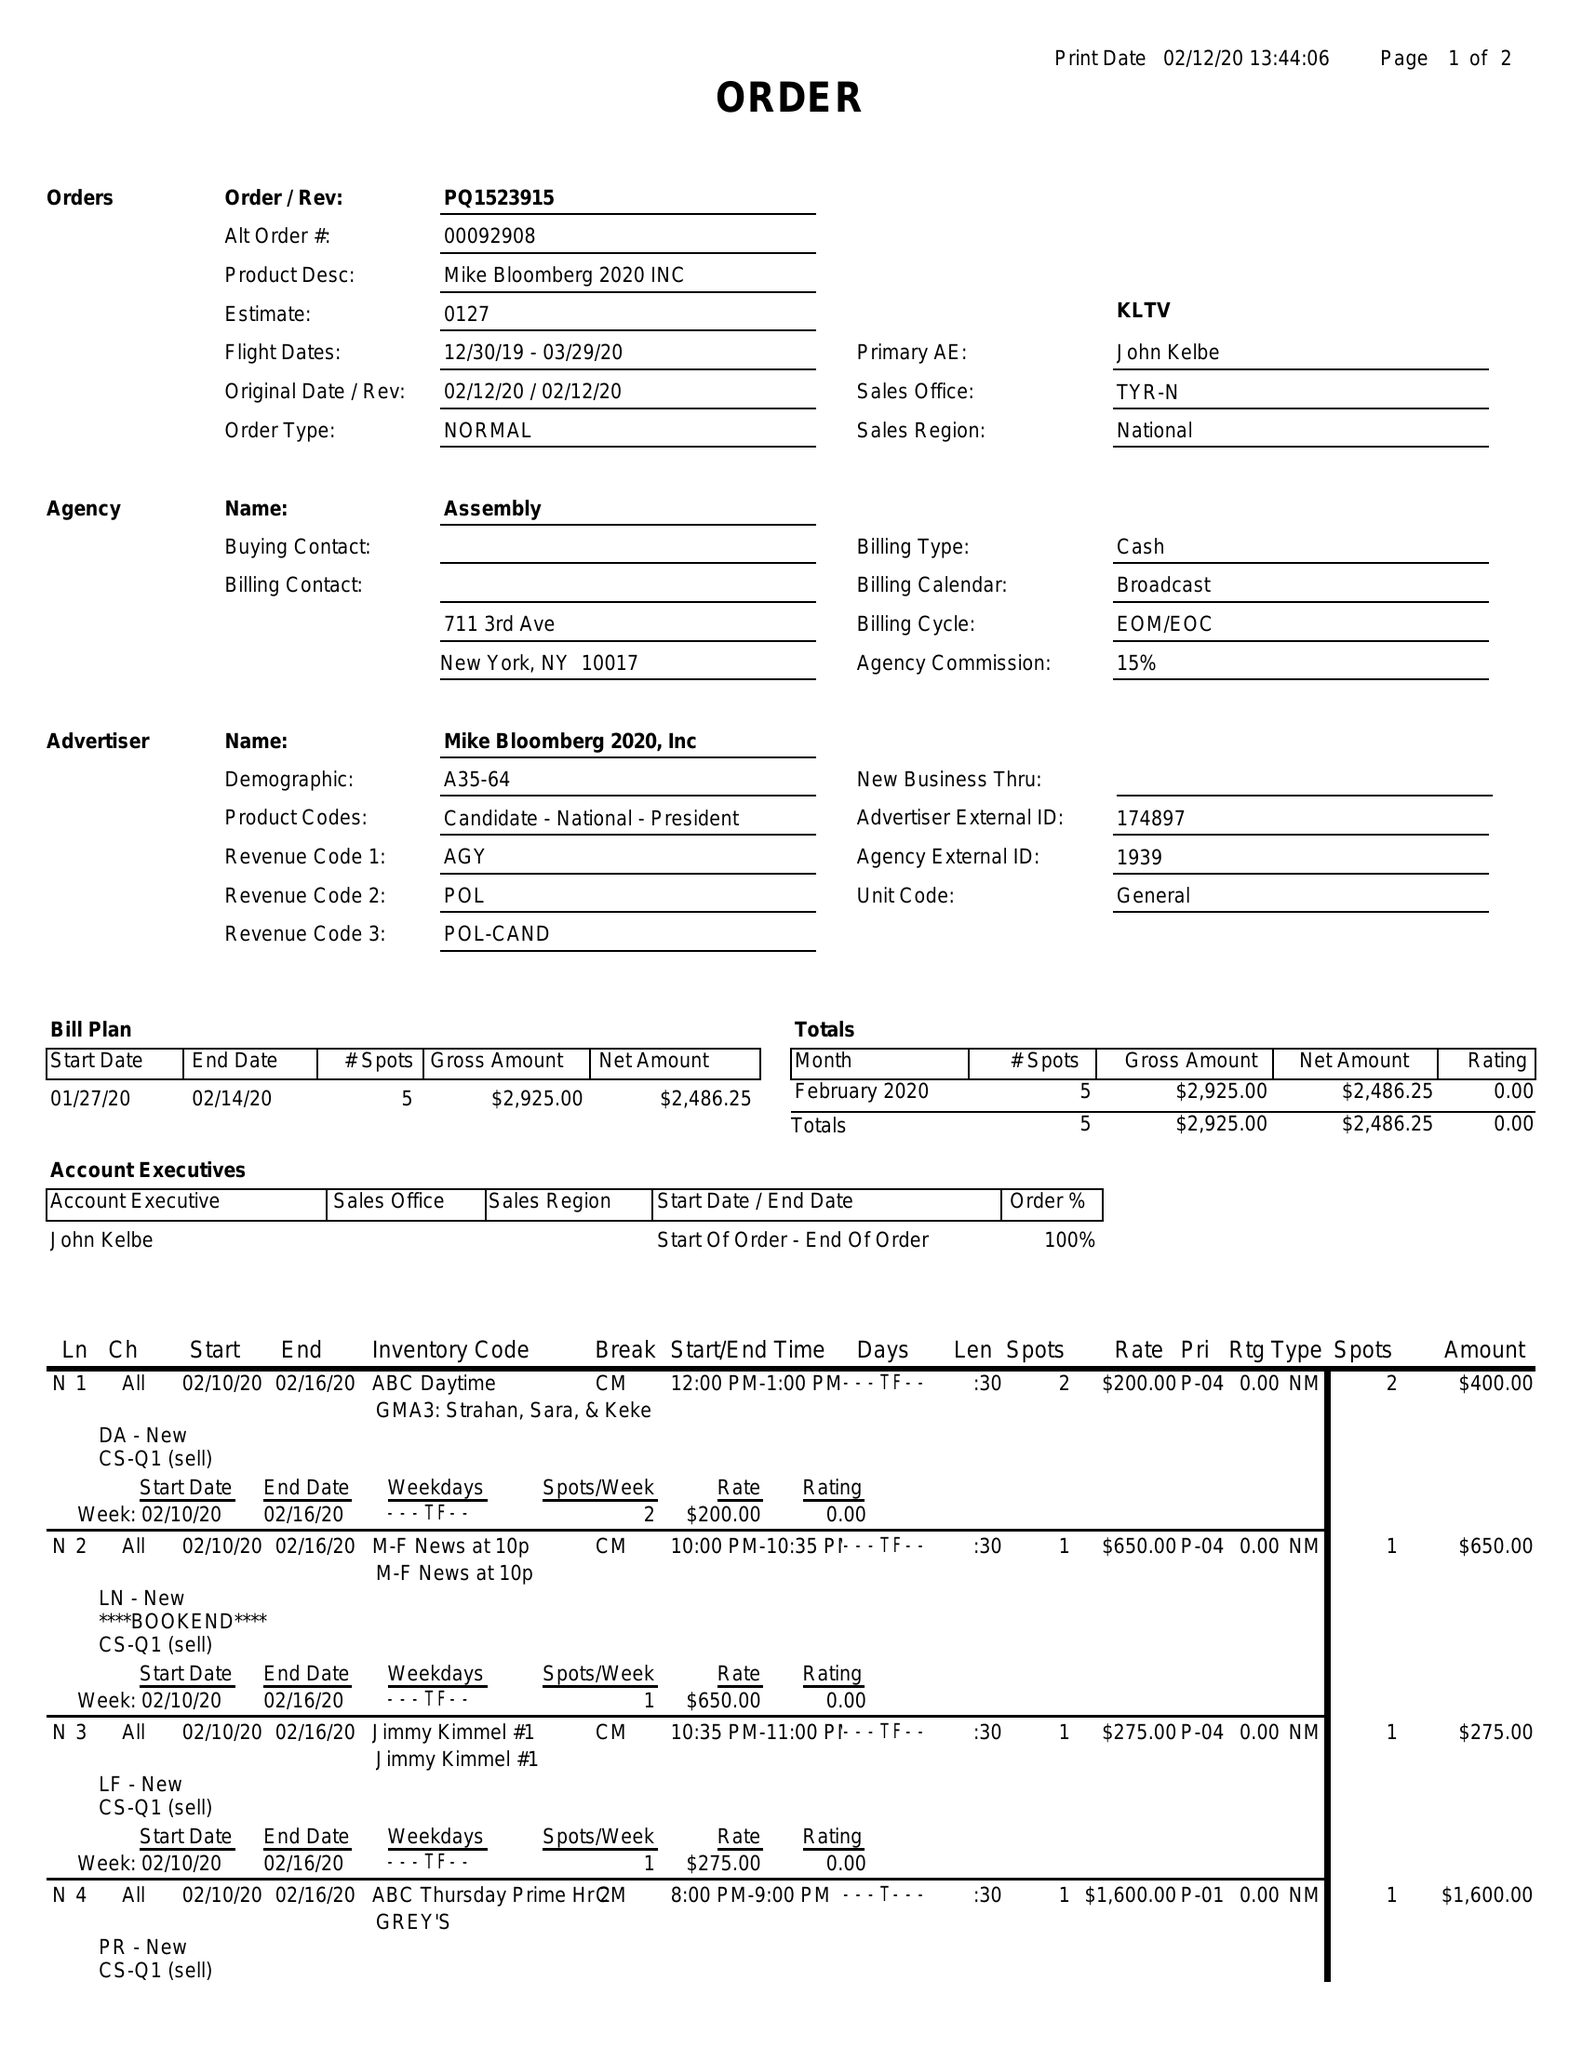What is the value for the advertiser?
Answer the question using a single word or phrase. MIKE BLOOMBERG 2020, INC 